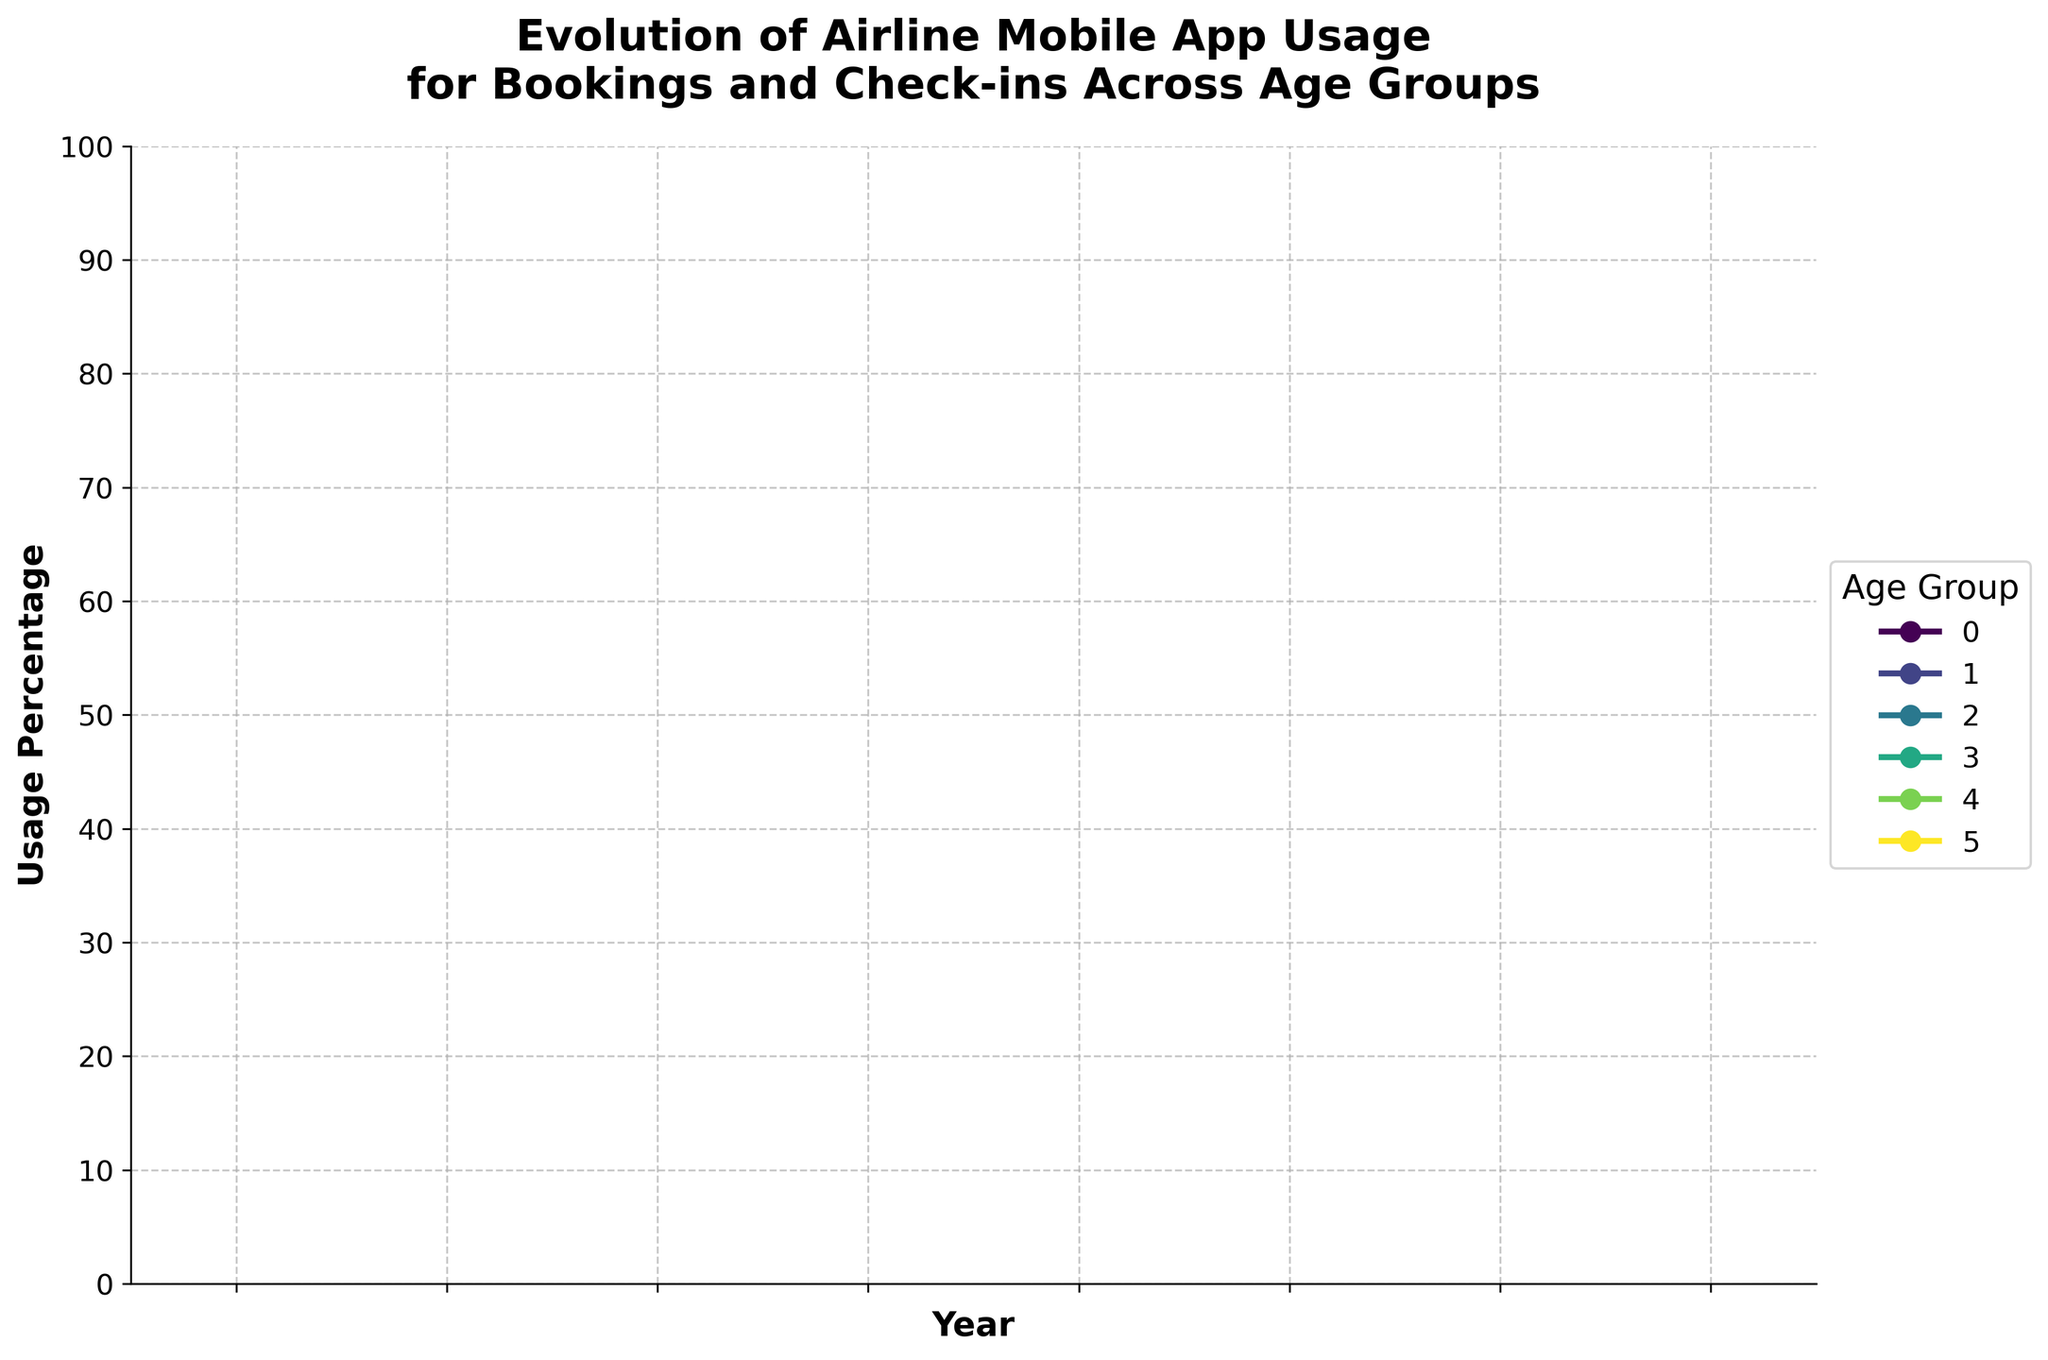What age group showed the highest mobile app usage in 2022? First, identify the 2022 values on the y-axis for each age group. The highest value is 82 found for the 25-34 age group.
Answer: 25-34 Which age group had the smallest increase in mobile app usage from 2015 to 2022? Calculate the difference for each age group between 2022 and 2015 usage values. The increase for each: 18-24 (60), 25-34 (61), 35-44 (61), 45-54 (59), 55-64 (55), 65+ (46). The smallest increase corresponds to the 65+ age group.
Answer: 65+ Between 2016 and 2018, which age group experienced the greatest increase in mobile app usage? Calculate the differences for each age group between 2016 and 2018. Differences: 18-24 (20), 25-34 (22), 35-44 (21), 45-54 (19), 55-64 (16), 65+ (12). The greatest increase was for the 25-34 age group.
Answer: 25-34 What is the average mobile app usage for the 35-44 age group over the years shown? Add the values for the 35-44 age group and divide by the number of years. Sum = 18 + 25 + 34 + 46 + 58 + 67 + 73 + 79 = 400. Average = 400/8 = 50.
Answer: 50 Is the mobile app usage in 2022 greater or equal to 70% for all age groups? Check if all usage percentages in 2022 for each age group are 70 or higher. Percentages: 75, 82, 79, 71, 63, 51. The 55-64 and 65+ groups are below 70%.
Answer: No Which year showed the most significant overall growth in mobile app usage across all age groups? Compare the year-to-year differences for each age group and sum them. Maximizing the total increase identifies the most significant growth year. Year 2018 showed notable increases (2017 vs. 2018 values) across all groups.
Answer: 2018 For which age groups did mobile app usage cross the 50% threshold before 2020? Identify the years usage exceeded 50% for each age group and check if they were before 2020. The age groups 18-24 (2019), 25-34 (2018), 35-44 (2019), and 45-54 (2019) crossed 50% before 2020.
Answer: 18-24, 25-34, 35-44, 45-54 Which two age groups had the closest mobile app usage percentages in 2020? Compare the 2020 values for all age groups: 61, 70, 67, 58, 49, 38. The closest percentages are 61 (18-24) and 58 (45-54).
Answer: 18-24 and 45-54 